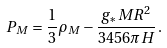Convert formula to latex. <formula><loc_0><loc_0><loc_500><loc_500>P _ { M } = \frac { 1 } { 3 } \rho _ { M } - \frac { g _ { * } M R ^ { 2 } } { 3 4 5 6 \pi H } \, .</formula> 